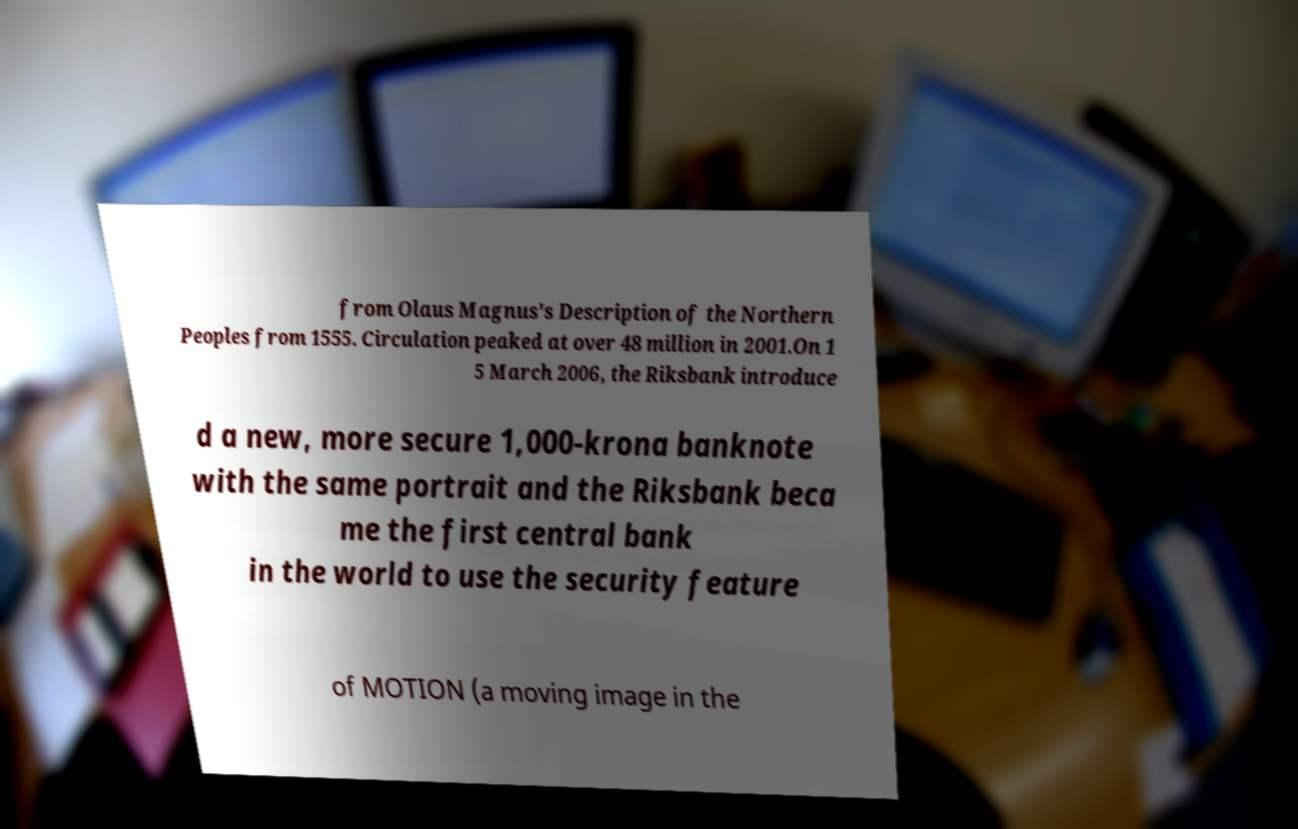Could you extract and type out the text from this image? from Olaus Magnus's Description of the Northern Peoples from 1555. Circulation peaked at over 48 million in 2001.On 1 5 March 2006, the Riksbank introduce d a new, more secure 1,000-krona banknote with the same portrait and the Riksbank beca me the first central bank in the world to use the security feature of MOTION (a moving image in the 